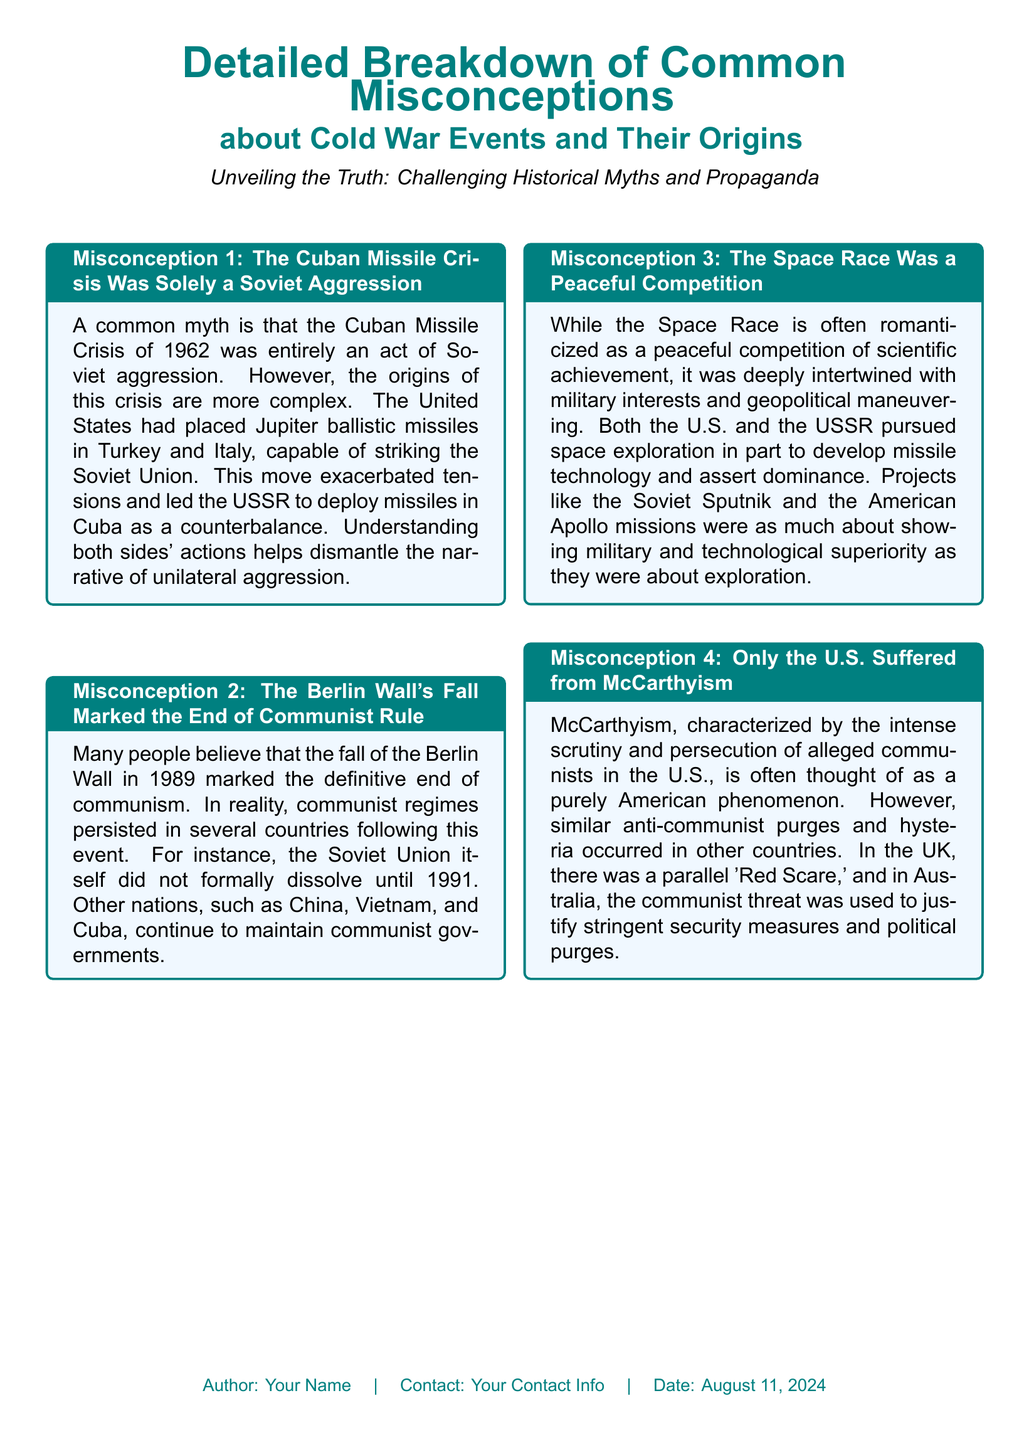What was the Cuban Missile Crisis driven by? The document indicates that the Cuban Missile Crisis was driven by complex factors, including U.S. missiles in Turkey and Italy prompting the USSR to deploy missiles in Cuba.
Answer: Complex factors What year did the fall of the Berlin Wall occur? The document states that the fall of the Berlin Wall happened in 1989, but communism persisted until 1991 in some countries.
Answer: 1989 Did the Space Race involve military interests? The document mentions that the Space Race was deeply intertwined with military interests and geopolitical maneuvering, not just peaceful competition.
Answer: Yes Which countries maintained communist governments after the fall of the Berlin Wall? The document lists countries such as China, Vietnam, and Cuba that continued to have communist governments after 1989.
Answer: China, Vietnam, Cuba Was McCarthyism limited to the United States? The document notes that similar anti-communist purges and hysteria occurred in other countries, such as the UK and Australia, indicating McCarthyism was not limited to the U.S.
Answer: No What was the title of the document? The document is titled "Detailed Breakdown of Common Misconceptions about Cold War Events and Their Origins."
Answer: Detailed Breakdown of Common Misconceptions about Cold War Events and Their Origins How many misconceptions are detailed in the document? The document details four misconceptions regarding Cold War events and their origins.
Answer: Four What is the overall theme of the document? The theme of the document focuses on unveiling the truth and challenging historical myths and propaganda related to the Cold War.
Answer: Unveiling the Truth 